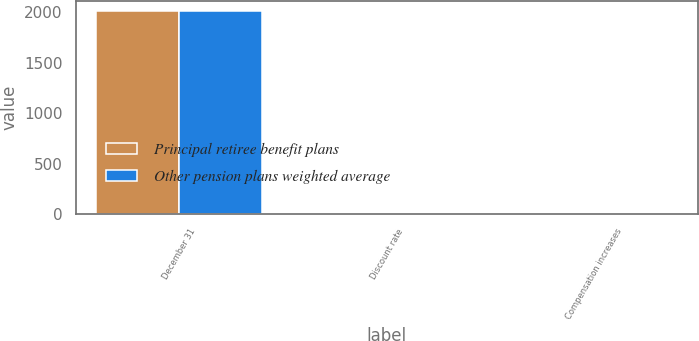Convert chart to OTSL. <chart><loc_0><loc_0><loc_500><loc_500><stacked_bar_chart><ecel><fcel>December 31<fcel>Discount rate<fcel>Compensation increases<nl><fcel>Principal retiree benefit plans<fcel>2015<fcel>3.33<fcel>3.32<nl><fcel>Other pension plans weighted average<fcel>2015<fcel>3.93<fcel>3.8<nl></chart> 